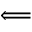Convert formula to latex. <formula><loc_0><loc_0><loc_500><loc_500>\Longleftarrow</formula> 